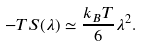<formula> <loc_0><loc_0><loc_500><loc_500>- T S ( \lambda ) \simeq \frac { k _ { B } T } { 6 } \lambda ^ { 2 } .</formula> 